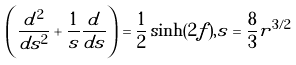Convert formula to latex. <formula><loc_0><loc_0><loc_500><loc_500>\left ( \frac { d ^ { 2 } } { d s ^ { 2 } } + \frac { 1 } { s } \frac { d } { d s } \right ) = \frac { 1 } { 2 } \sinh ( 2 f ) , s = \frac { 8 } { 3 } r ^ { 3 / 2 }</formula> 